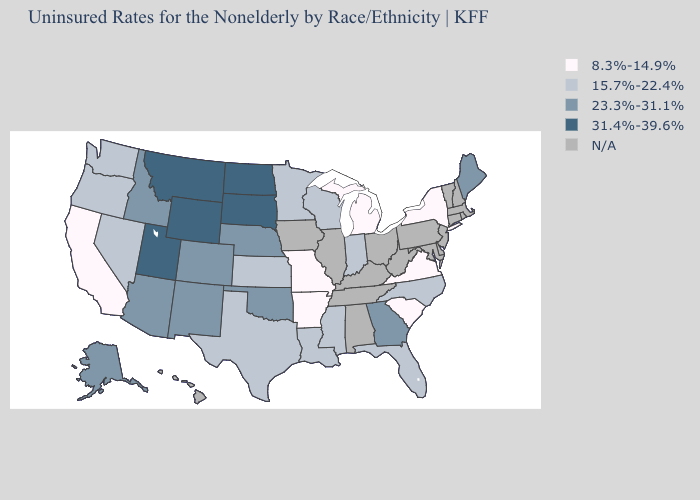Name the states that have a value in the range N/A?
Give a very brief answer. Alabama, Connecticut, Delaware, Hawaii, Illinois, Iowa, Kentucky, Maryland, Massachusetts, New Hampshire, New Jersey, Ohio, Pennsylvania, Rhode Island, Tennessee, Vermont, West Virginia. What is the highest value in states that border Florida?
Be succinct. 23.3%-31.1%. What is the highest value in the West ?
Be succinct. 31.4%-39.6%. Name the states that have a value in the range 15.7%-22.4%?
Short answer required. Florida, Indiana, Kansas, Louisiana, Minnesota, Mississippi, Nevada, North Carolina, Oregon, Texas, Washington, Wisconsin. Which states hav the highest value in the MidWest?
Write a very short answer. North Dakota, South Dakota. What is the value of Iowa?
Be succinct. N/A. Which states hav the highest value in the West?
Concise answer only. Montana, Utah, Wyoming. Does the map have missing data?
Quick response, please. Yes. How many symbols are there in the legend?
Concise answer only. 5. Which states have the highest value in the USA?
Write a very short answer. Montana, North Dakota, South Dakota, Utah, Wyoming. What is the value of Alabama?
Write a very short answer. N/A. What is the highest value in the USA?
Short answer required. 31.4%-39.6%. What is the highest value in the USA?
Keep it brief. 31.4%-39.6%. Name the states that have a value in the range 31.4%-39.6%?
Answer briefly. Montana, North Dakota, South Dakota, Utah, Wyoming. What is the value of Florida?
Keep it brief. 15.7%-22.4%. 